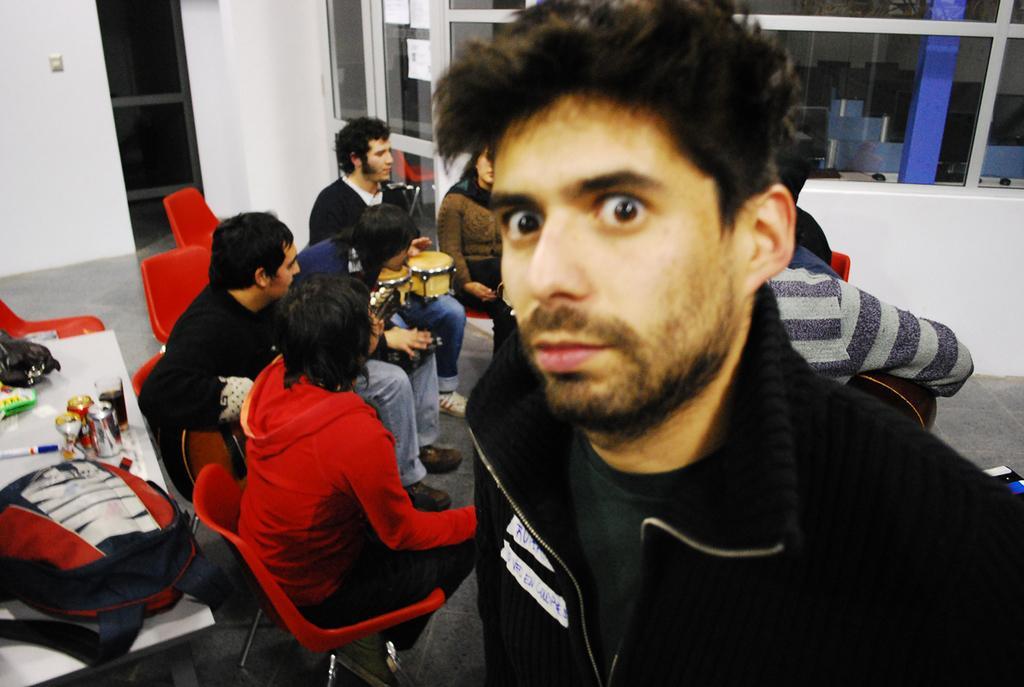Describe this image in one or two sentences. In the foreground of the image there is a person wearing a jacket. In the background of the image there are people sitting on chairs. To the left side of the image there is a table on which there is bag and other objects. In the background of the image there is wall. There is a glass door. 